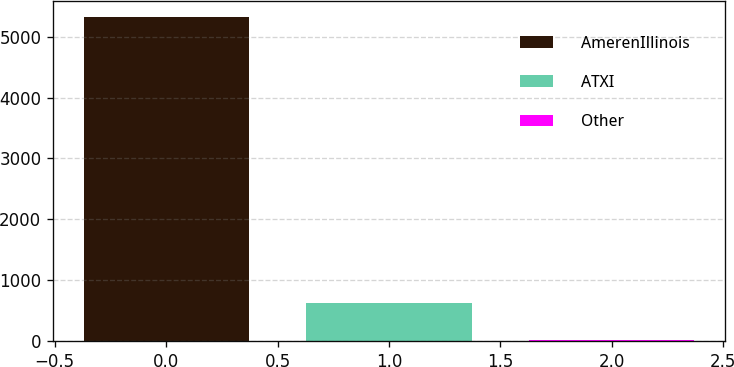<chart> <loc_0><loc_0><loc_500><loc_500><bar_chart><fcel>AmerenIllinois<fcel>ATXI<fcel>Other<nl><fcel>5325<fcel>625<fcel>15<nl></chart> 